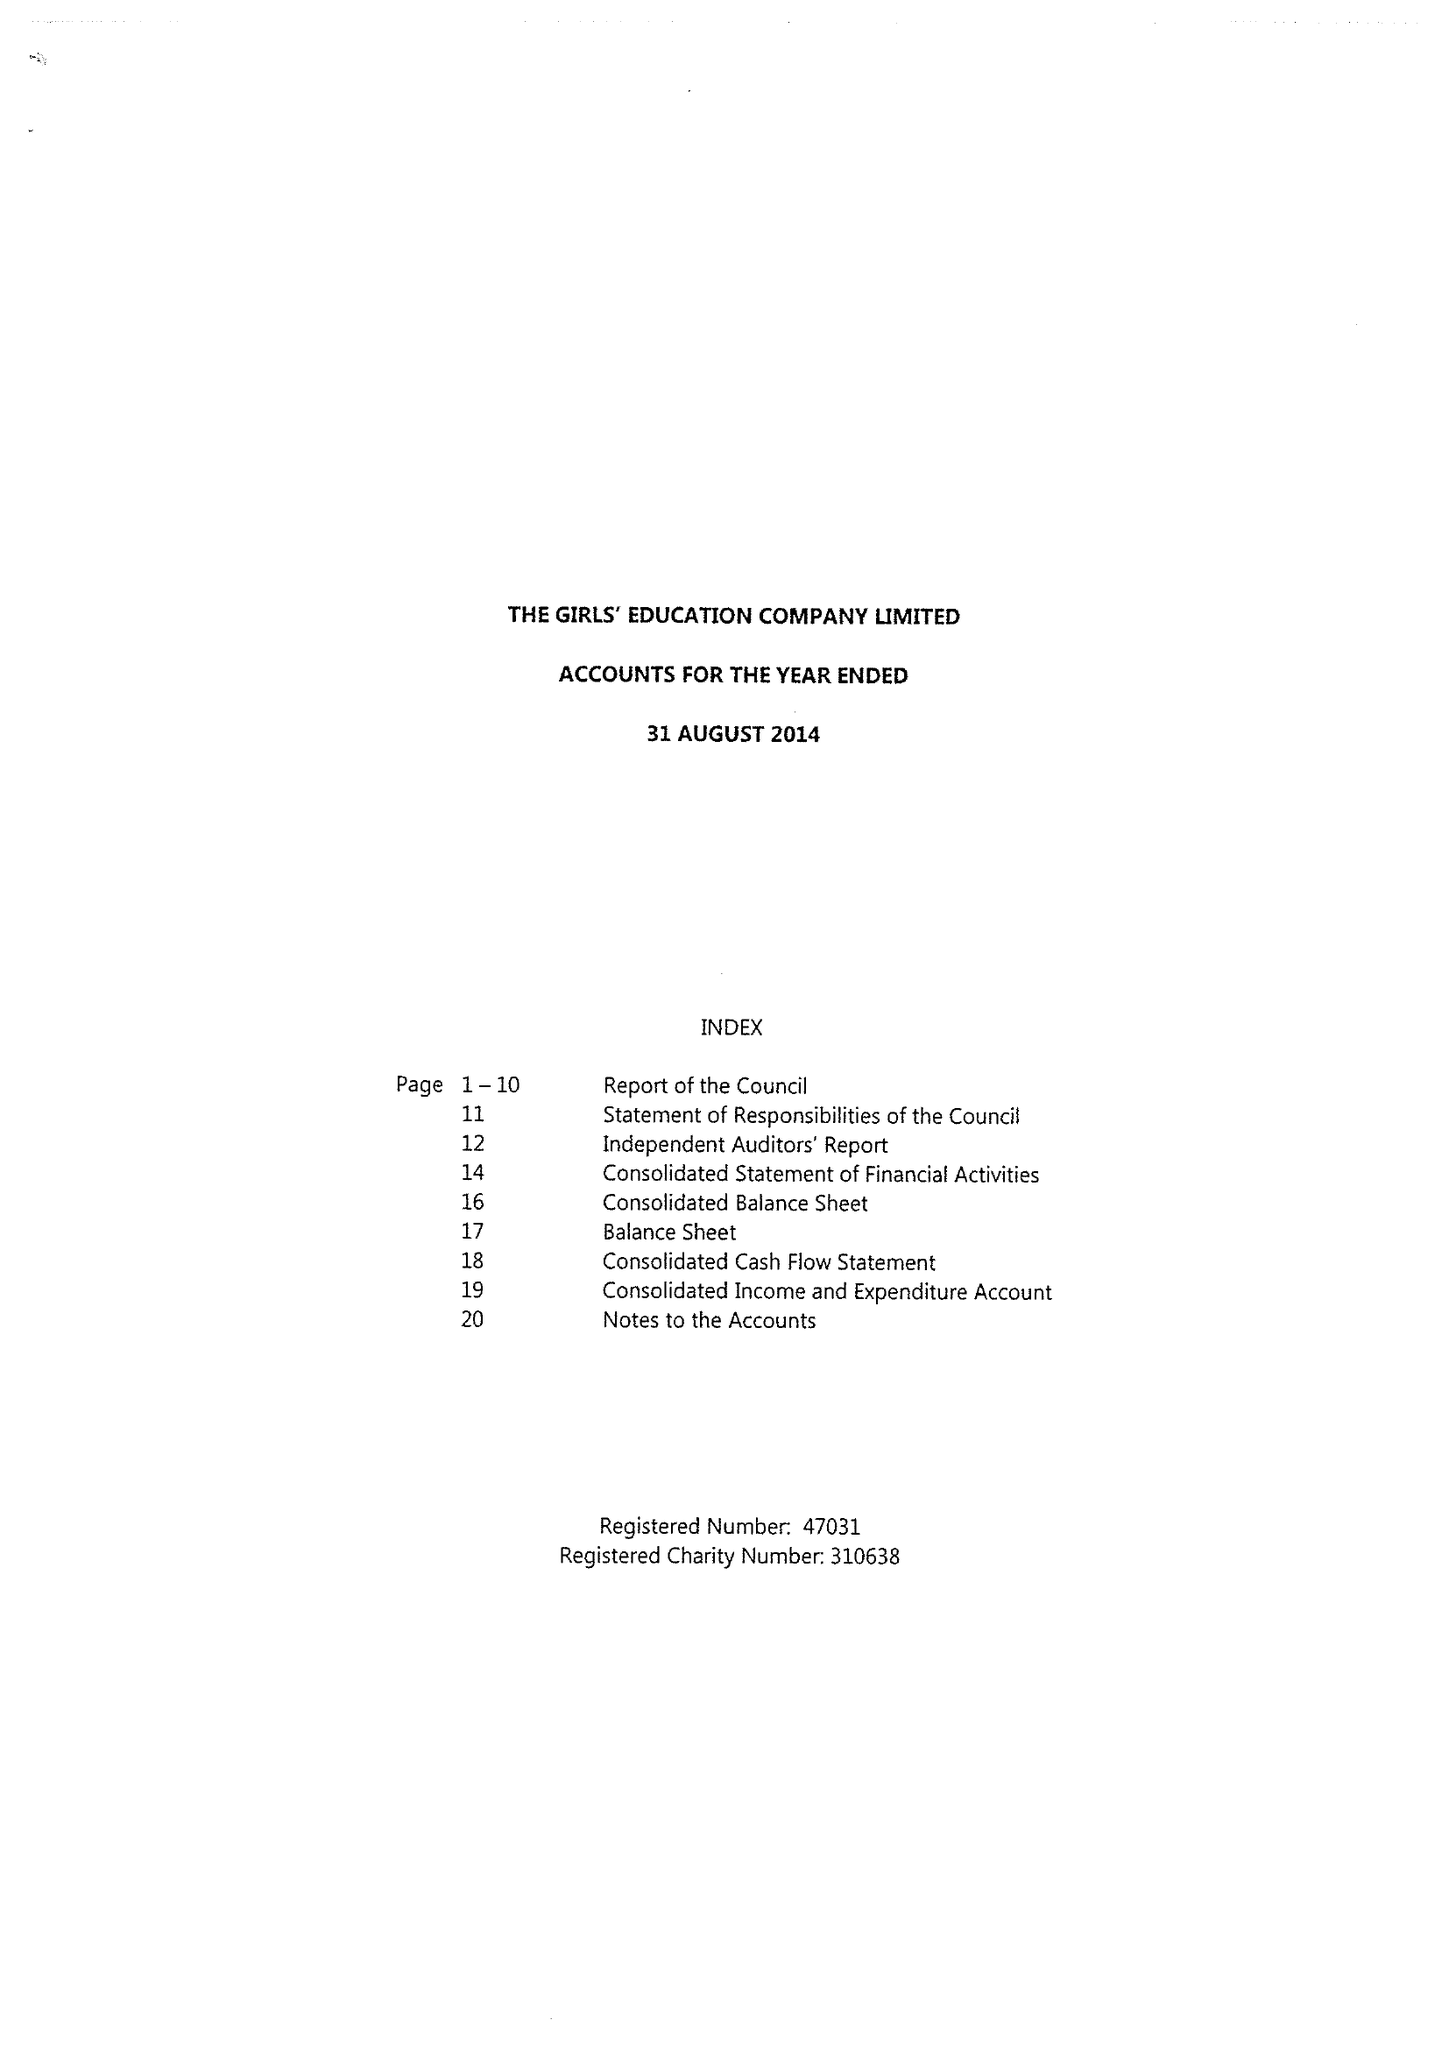What is the value for the report_date?
Answer the question using a single word or phrase. 2014-08-31 